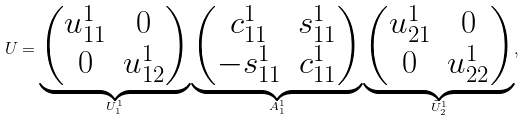Convert formula to latex. <formula><loc_0><loc_0><loc_500><loc_500>U = \underbrace { \begin{pmatrix} u ^ { 1 } _ { 1 1 } & 0 \\ 0 & u ^ { 1 } _ { 1 2 } \end{pmatrix} } _ { U ^ { 1 } _ { 1 } } \underbrace { \begin{pmatrix} c ^ { 1 } _ { 1 1 } & s ^ { 1 } _ { 1 1 } \\ - s ^ { 1 } _ { 1 1 } & c ^ { 1 } _ { 1 1 } \end{pmatrix} } _ { A ^ { 1 } _ { 1 } } \underbrace { \begin{pmatrix} u ^ { 1 } _ { 2 1 } & 0 \\ 0 & u ^ { 1 } _ { 2 2 } \end{pmatrix} } _ { \tilde { U } ^ { 1 } _ { 2 } } ,</formula> 